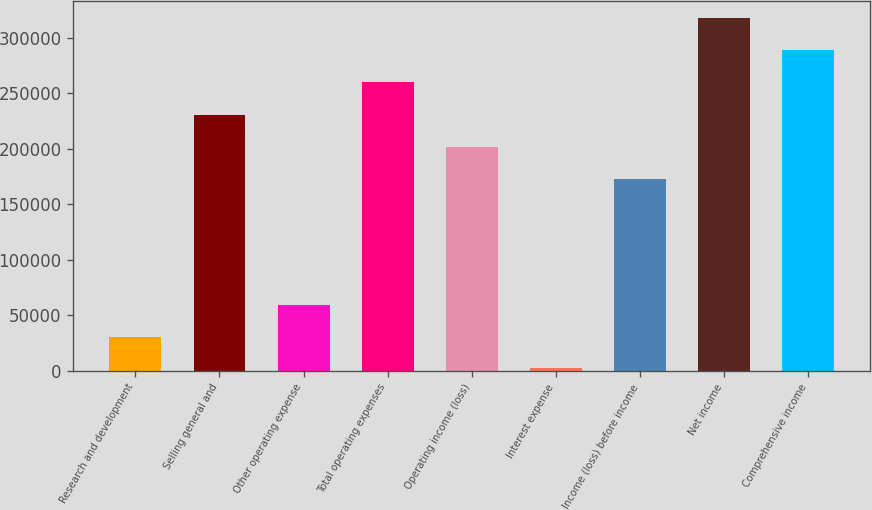Convert chart. <chart><loc_0><loc_0><loc_500><loc_500><bar_chart><fcel>Research and development<fcel>Selling general and<fcel>Other operating expense<fcel>Total operating expenses<fcel>Operating income (loss)<fcel>Interest expense<fcel>Income (loss) before income<fcel>Net income<fcel>Comprehensive income<nl><fcel>30617.7<fcel>229998<fcel>59129.4<fcel>260247<fcel>201487<fcel>2106<fcel>172975<fcel>317270<fcel>288759<nl></chart> 